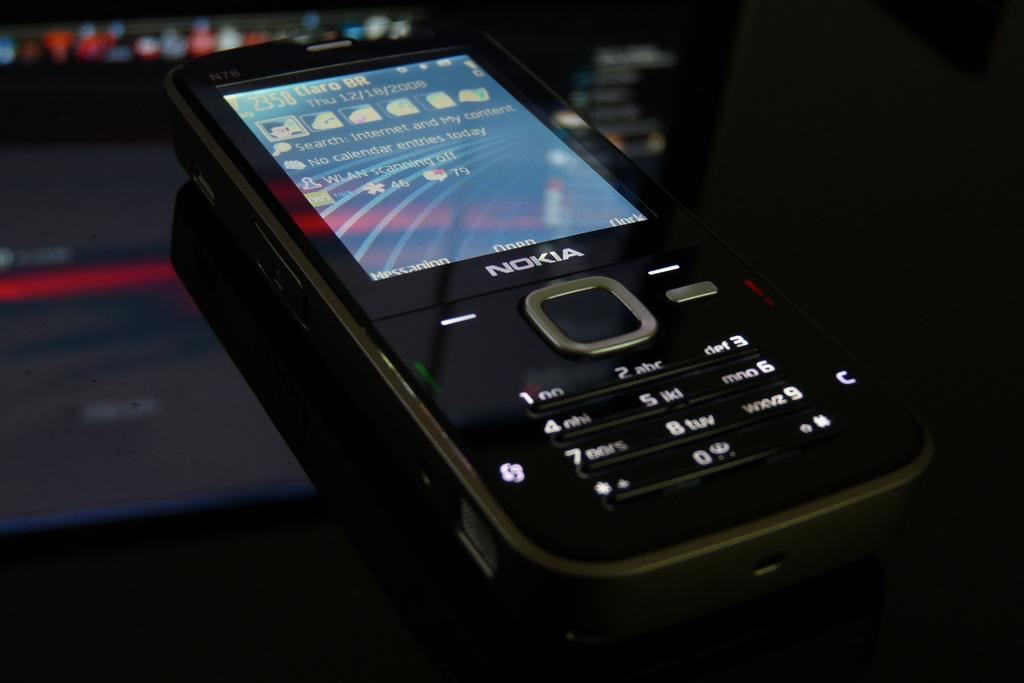<image>
Write a terse but informative summary of the picture. a black nokia phone with white keys and folders displayed on the screen 